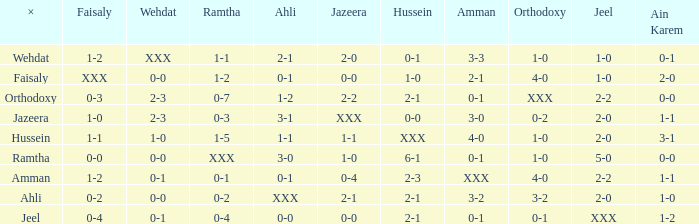What is ahli when ramtha is 0-4? 0-0. 